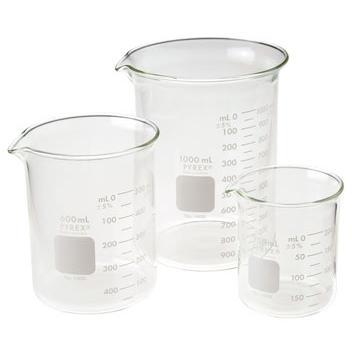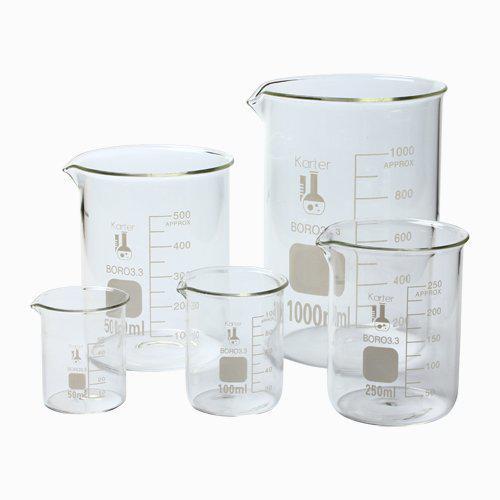The first image is the image on the left, the second image is the image on the right. For the images displayed, is the sentence "Right image contains a single empty glass vessel shaped like a cylinder with a small pour spout on one side." factually correct? Answer yes or no. No. The first image is the image on the left, the second image is the image on the right. Given the left and right images, does the statement "There are two flasks in the pair of images." hold true? Answer yes or no. No. 